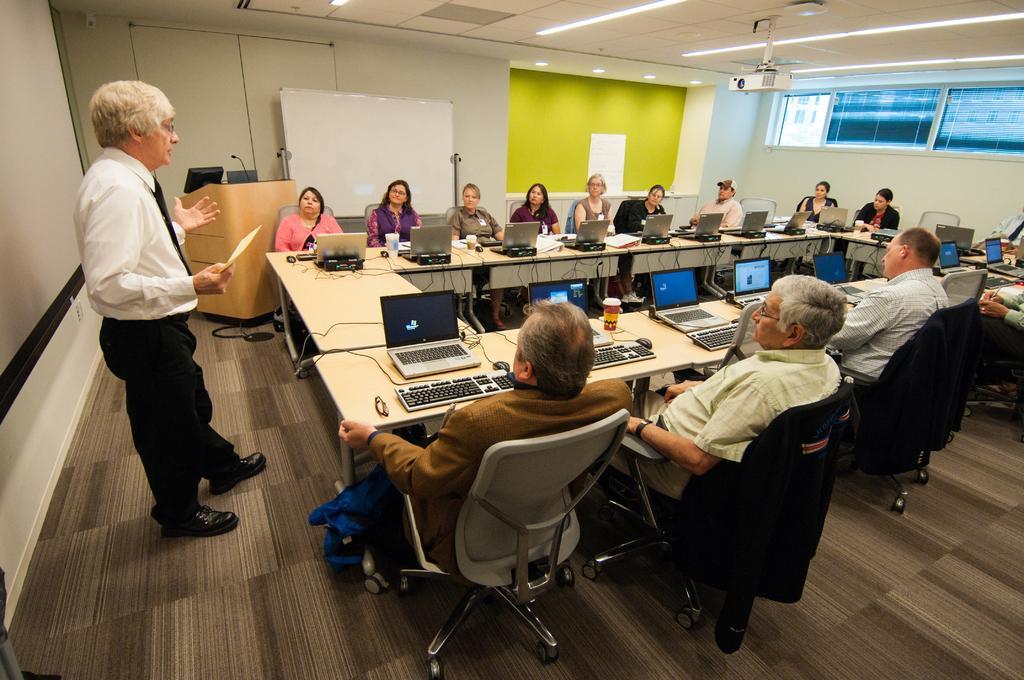In one or two sentences, can you explain what this image depicts? This picture describe about the group of people sitting in the meeting room around the table. A man in front wearing a white shirt, black pant and shoe is standing and discussing with them. behind we can see the projector screen and a yellow wall on the straight right side. On the table we can see the some laptop , papers and coffee mugs. On the top ceiling same spot light and projector lens is placed. 